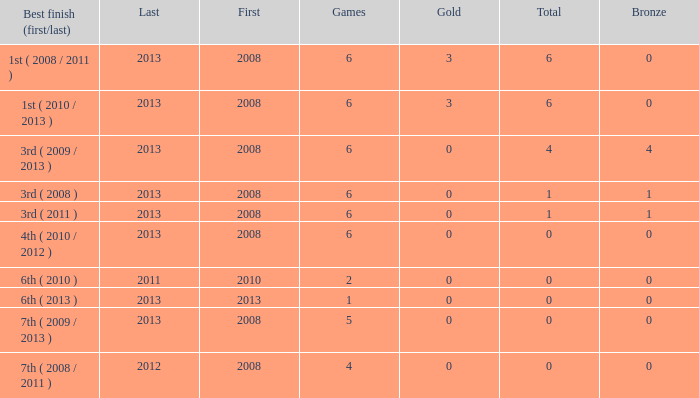How many bronzes associated with over 0 total medals, 3 golds, and over 6 games? None. 